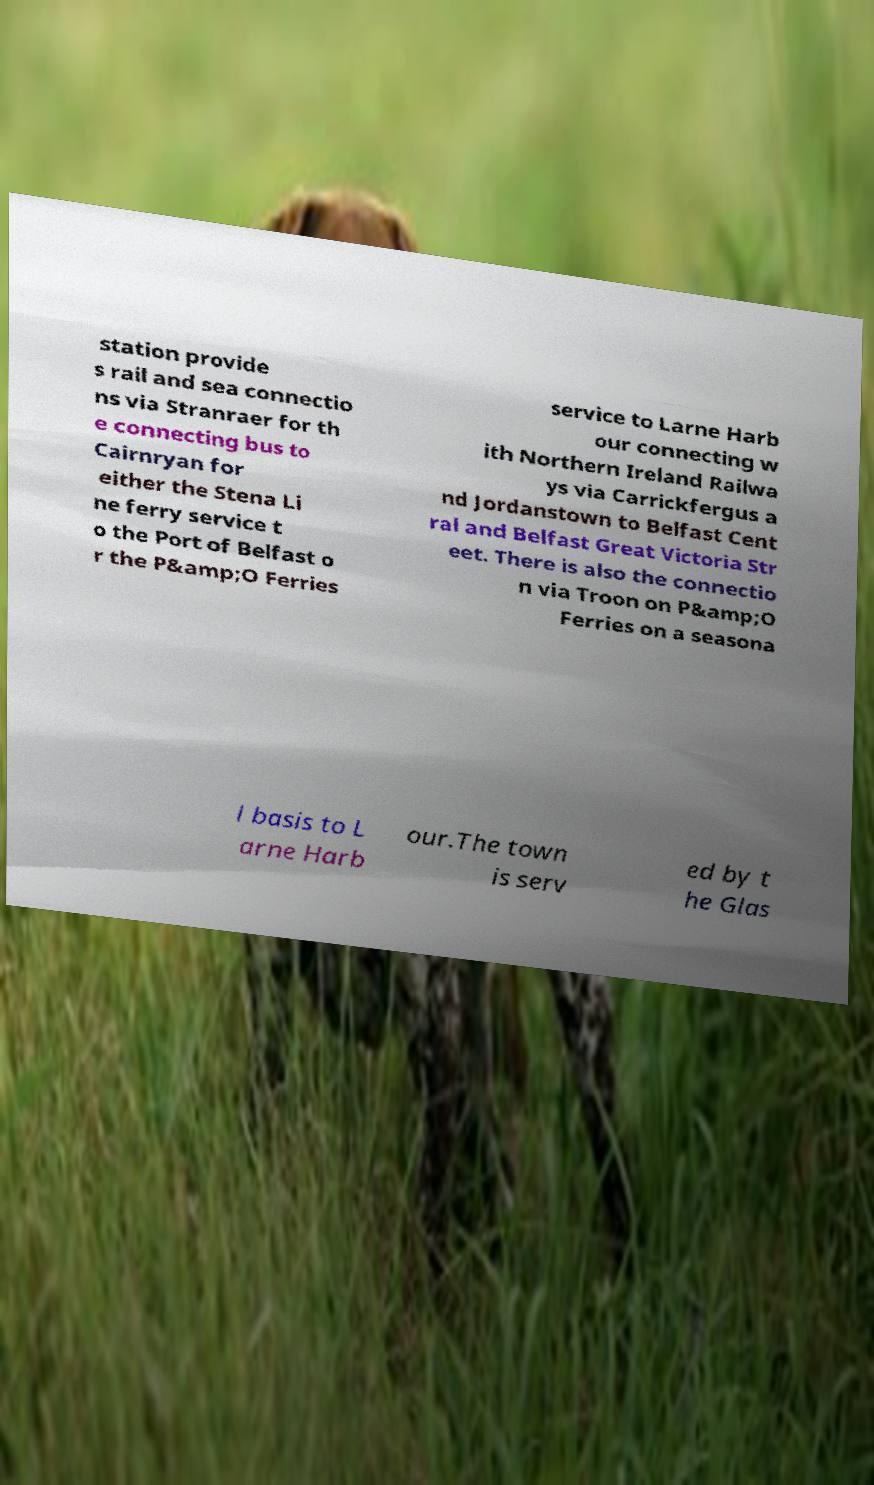Could you assist in decoding the text presented in this image and type it out clearly? station provide s rail and sea connectio ns via Stranraer for th e connecting bus to Cairnryan for either the Stena Li ne ferry service t o the Port of Belfast o r the P&amp;O Ferries service to Larne Harb our connecting w ith Northern Ireland Railwa ys via Carrickfergus a nd Jordanstown to Belfast Cent ral and Belfast Great Victoria Str eet. There is also the connectio n via Troon on P&amp;O Ferries on a seasona l basis to L arne Harb our.The town is serv ed by t he Glas 